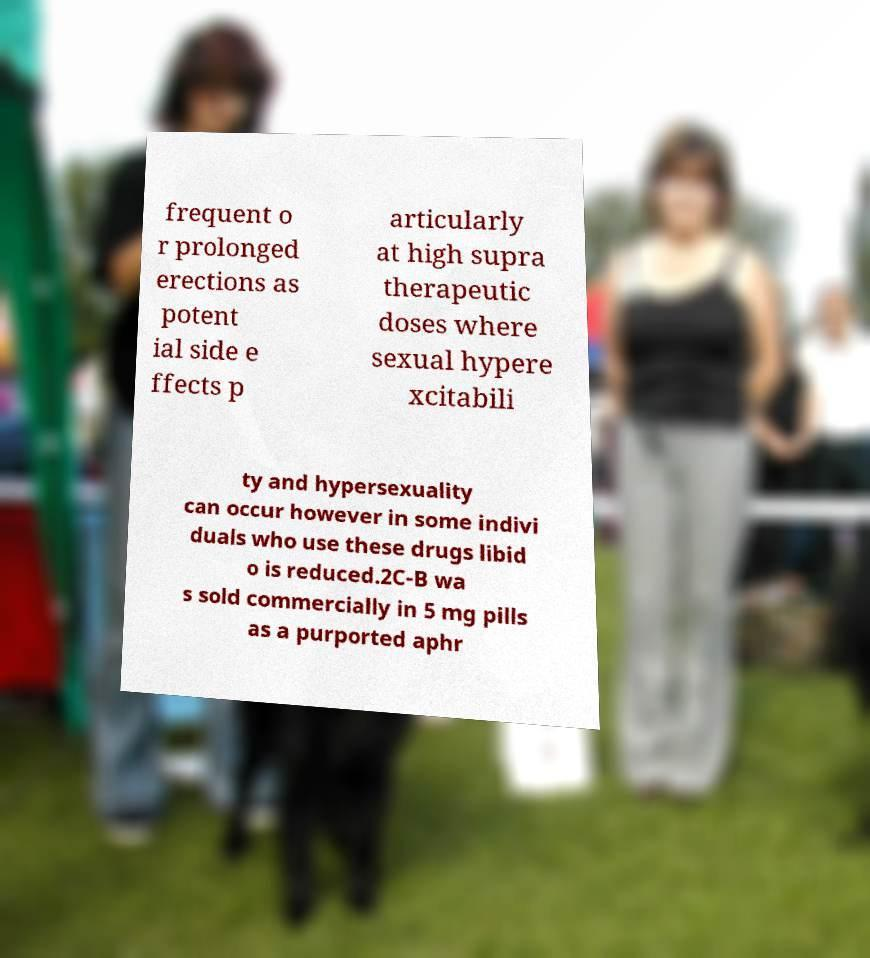Could you extract and type out the text from this image? frequent o r prolonged erections as potent ial side e ffects p articularly at high supra therapeutic doses where sexual hypere xcitabili ty and hypersexuality can occur however in some indivi duals who use these drugs libid o is reduced.2C-B wa s sold commercially in 5 mg pills as a purported aphr 